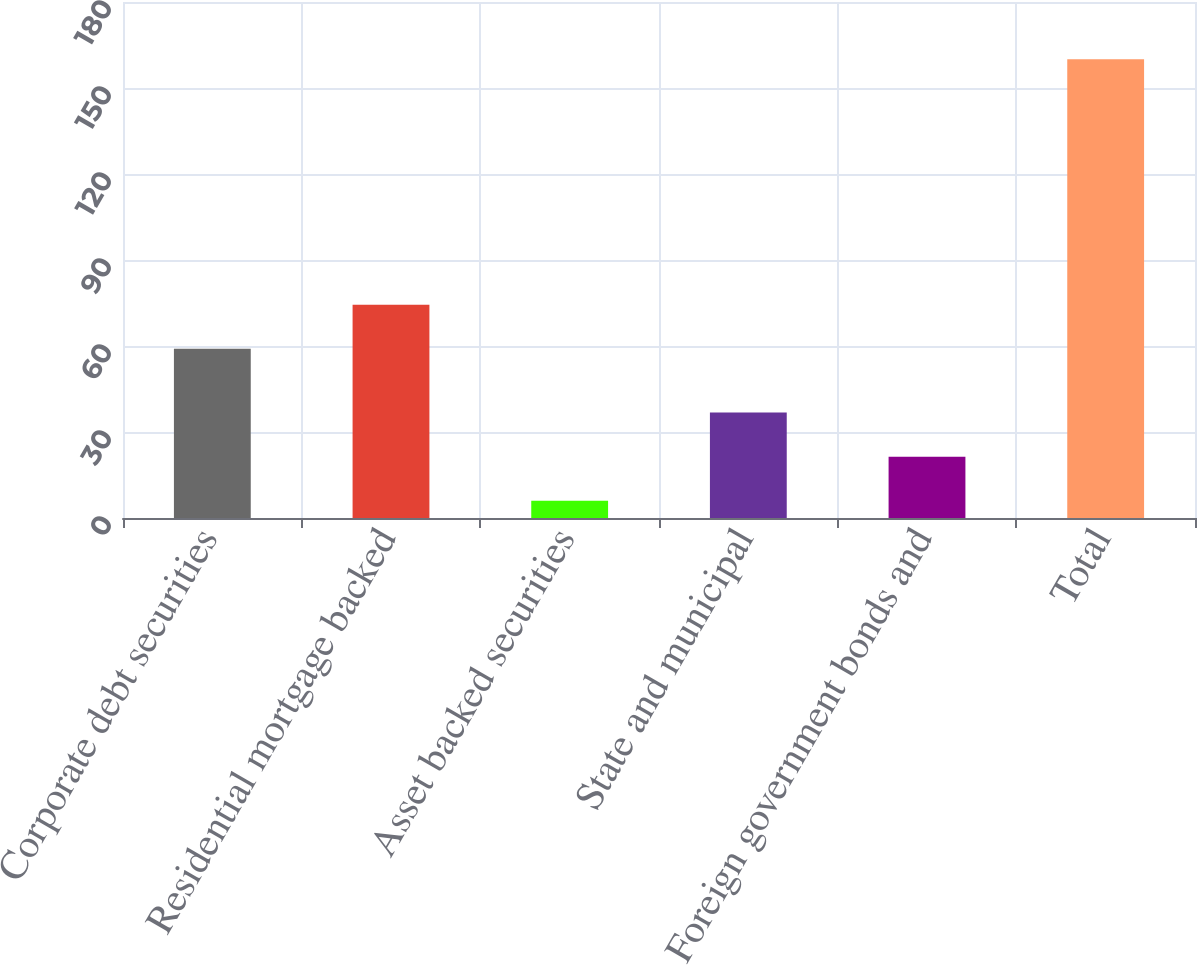<chart> <loc_0><loc_0><loc_500><loc_500><bar_chart><fcel>Corporate debt securities<fcel>Residential mortgage backed<fcel>Asset backed securities<fcel>State and municipal<fcel>Foreign government bonds and<fcel>Total<nl><fcel>59<fcel>74.4<fcel>6<fcel>36.8<fcel>21.4<fcel>160<nl></chart> 